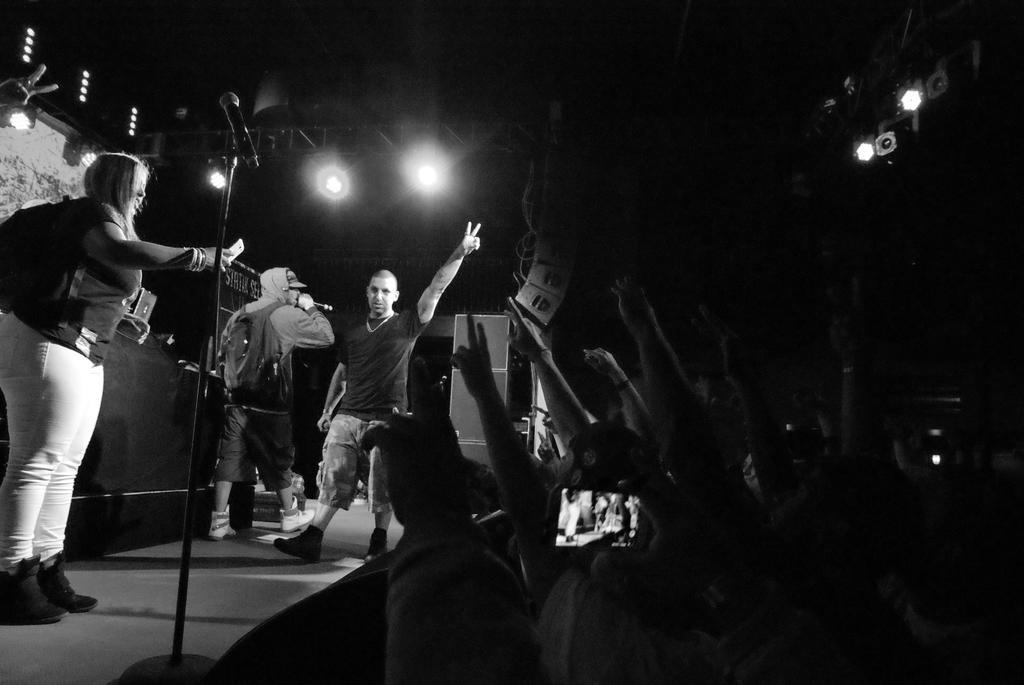Could you give a brief overview of what you see in this image? This is a black and white image. This image is clicked outside. There are lights on the top. People are standing here. There is a woman on the left side and two people are walking in the middle of the image. One of them is holding Mike and he also has bag. There are lights on the on left side too. 